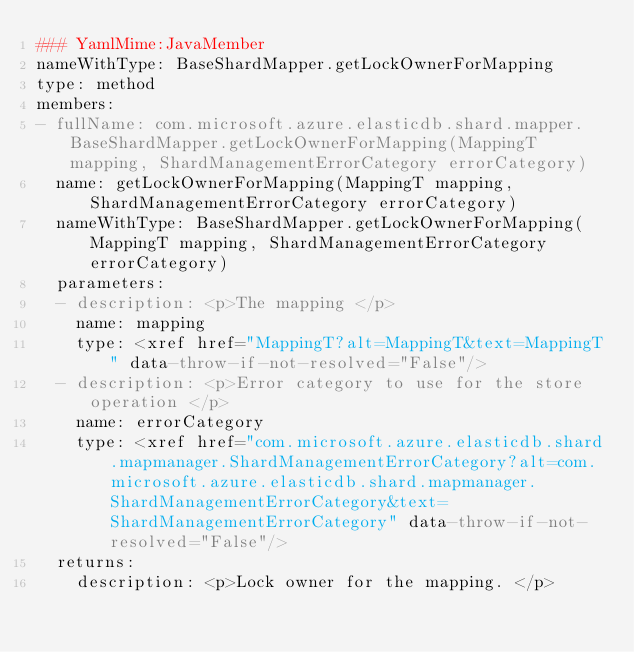<code> <loc_0><loc_0><loc_500><loc_500><_YAML_>### YamlMime:JavaMember
nameWithType: BaseShardMapper.getLockOwnerForMapping
type: method
members:
- fullName: com.microsoft.azure.elasticdb.shard.mapper.BaseShardMapper.getLockOwnerForMapping(MappingT mapping, ShardManagementErrorCategory errorCategory)
  name: getLockOwnerForMapping(MappingT mapping, ShardManagementErrorCategory errorCategory)
  nameWithType: BaseShardMapper.getLockOwnerForMapping(MappingT mapping, ShardManagementErrorCategory errorCategory)
  parameters:
  - description: <p>The mapping </p>
    name: mapping
    type: <xref href="MappingT?alt=MappingT&text=MappingT" data-throw-if-not-resolved="False"/>
  - description: <p>Error category to use for the store operation </p>
    name: errorCategory
    type: <xref href="com.microsoft.azure.elasticdb.shard.mapmanager.ShardManagementErrorCategory?alt=com.microsoft.azure.elasticdb.shard.mapmanager.ShardManagementErrorCategory&text=ShardManagementErrorCategory" data-throw-if-not-resolved="False"/>
  returns:
    description: <p>Lock owner for the mapping. </p></code> 